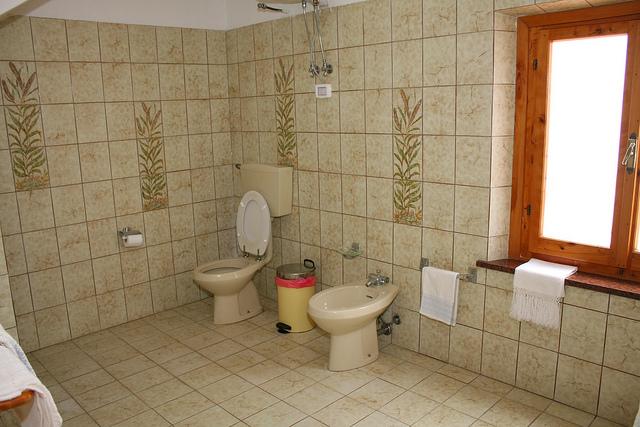Where is the towel?
Give a very brief answer. Rack. Is this a large bathroom?
Concise answer only. Yes. What designs are on the wall?
Be succinct. Plants. What is the room in the picture?
Write a very short answer. Bathroom. How many towels are in the room?
Concise answer only. 3. What does the handle on the wall do?
Be succinct. Flush. How many towels are in the picture?
Write a very short answer. 3. Who cleaned this room?
Answer briefly. Maid. 